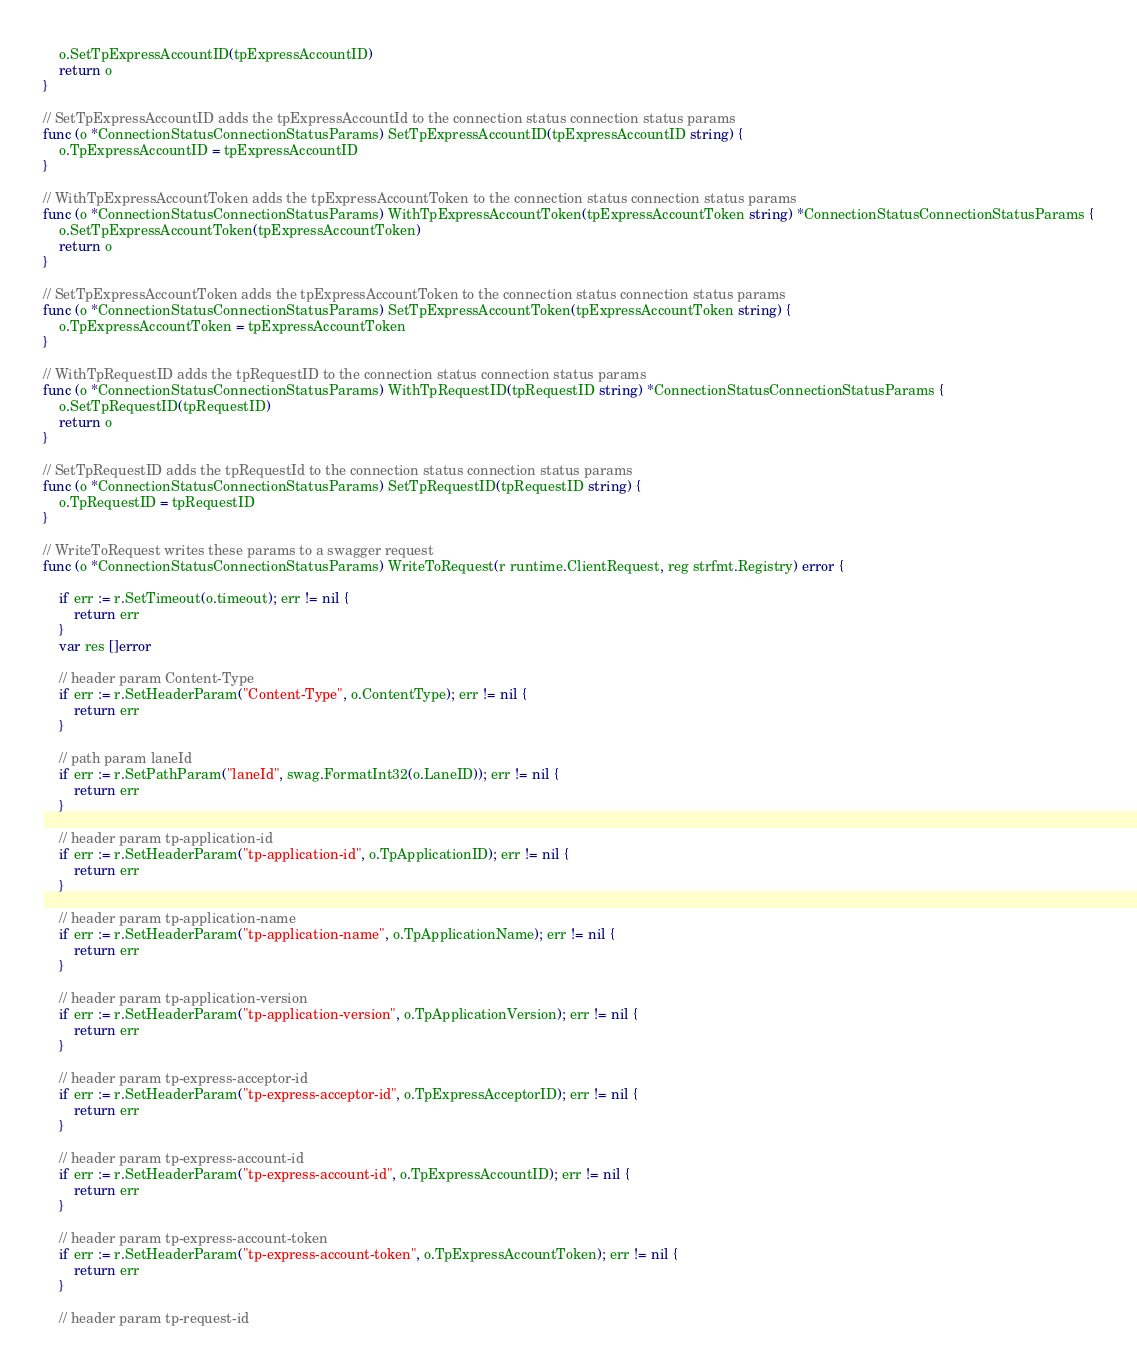<code> <loc_0><loc_0><loc_500><loc_500><_Go_>	o.SetTpExpressAccountID(tpExpressAccountID)
	return o
}

// SetTpExpressAccountID adds the tpExpressAccountId to the connection status connection status params
func (o *ConnectionStatusConnectionStatusParams) SetTpExpressAccountID(tpExpressAccountID string) {
	o.TpExpressAccountID = tpExpressAccountID
}

// WithTpExpressAccountToken adds the tpExpressAccountToken to the connection status connection status params
func (o *ConnectionStatusConnectionStatusParams) WithTpExpressAccountToken(tpExpressAccountToken string) *ConnectionStatusConnectionStatusParams {
	o.SetTpExpressAccountToken(tpExpressAccountToken)
	return o
}

// SetTpExpressAccountToken adds the tpExpressAccountToken to the connection status connection status params
func (o *ConnectionStatusConnectionStatusParams) SetTpExpressAccountToken(tpExpressAccountToken string) {
	o.TpExpressAccountToken = tpExpressAccountToken
}

// WithTpRequestID adds the tpRequestID to the connection status connection status params
func (o *ConnectionStatusConnectionStatusParams) WithTpRequestID(tpRequestID string) *ConnectionStatusConnectionStatusParams {
	o.SetTpRequestID(tpRequestID)
	return o
}

// SetTpRequestID adds the tpRequestId to the connection status connection status params
func (o *ConnectionStatusConnectionStatusParams) SetTpRequestID(tpRequestID string) {
	o.TpRequestID = tpRequestID
}

// WriteToRequest writes these params to a swagger request
func (o *ConnectionStatusConnectionStatusParams) WriteToRequest(r runtime.ClientRequest, reg strfmt.Registry) error {

	if err := r.SetTimeout(o.timeout); err != nil {
		return err
	}
	var res []error

	// header param Content-Type
	if err := r.SetHeaderParam("Content-Type", o.ContentType); err != nil {
		return err
	}

	// path param laneId
	if err := r.SetPathParam("laneId", swag.FormatInt32(o.LaneID)); err != nil {
		return err
	}

	// header param tp-application-id
	if err := r.SetHeaderParam("tp-application-id", o.TpApplicationID); err != nil {
		return err
	}

	// header param tp-application-name
	if err := r.SetHeaderParam("tp-application-name", o.TpApplicationName); err != nil {
		return err
	}

	// header param tp-application-version
	if err := r.SetHeaderParam("tp-application-version", o.TpApplicationVersion); err != nil {
		return err
	}

	// header param tp-express-acceptor-id
	if err := r.SetHeaderParam("tp-express-acceptor-id", o.TpExpressAcceptorID); err != nil {
		return err
	}

	// header param tp-express-account-id
	if err := r.SetHeaderParam("tp-express-account-id", o.TpExpressAccountID); err != nil {
		return err
	}

	// header param tp-express-account-token
	if err := r.SetHeaderParam("tp-express-account-token", o.TpExpressAccountToken); err != nil {
		return err
	}

	// header param tp-request-id</code> 